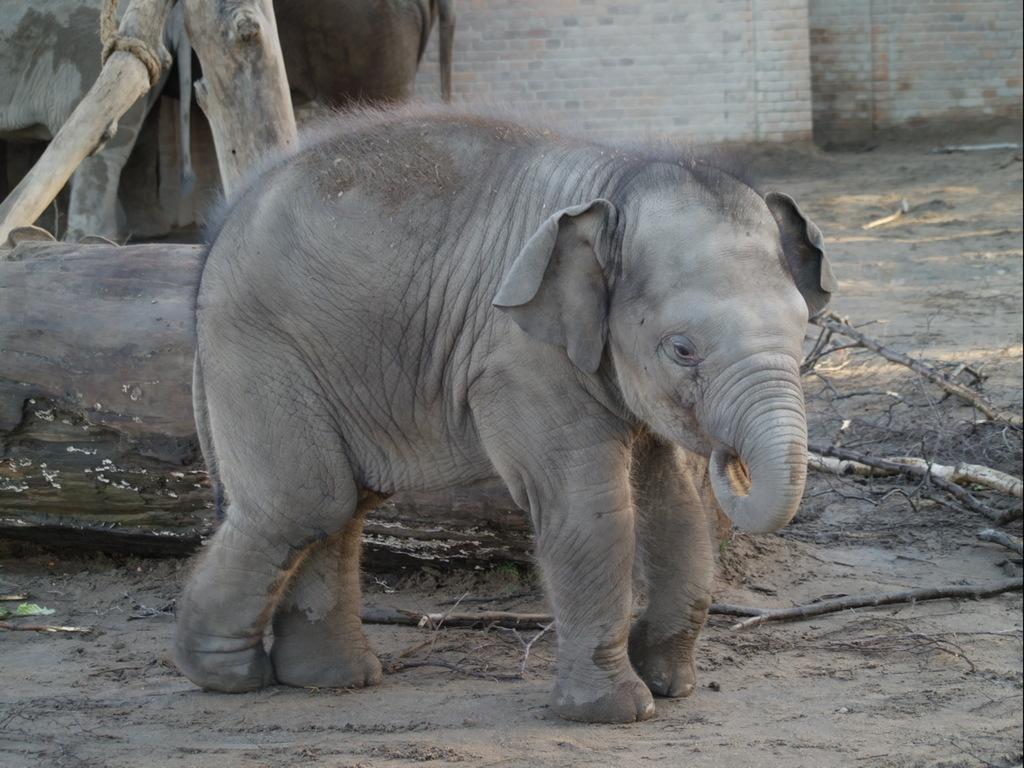What animals can be seen in the image? There are elephants in the image. What objects are present in the image? There are logs and sticks in the image. What can be seen in the background of the image? There is a wall in the background of the image. What is visible at the bottom of the image? There is ground visible at the bottom of the image. What type of drug is being used by the elephants in the image? There is no drug present in the image; it features elephants, logs, and sticks. How many potatoes can be seen in the image? There are no potatoes present in the image. 